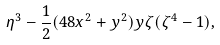<formula> <loc_0><loc_0><loc_500><loc_500>\eta ^ { 3 } - \frac { 1 } { 2 } ( 4 8 x ^ { 2 } + y ^ { 2 } ) y \zeta ( \zeta ^ { 4 } - 1 ) ,</formula> 